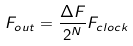<formula> <loc_0><loc_0><loc_500><loc_500>F _ { o u t } = \frac { \Delta F } { 2 ^ { N } } F _ { c l o c k }</formula> 